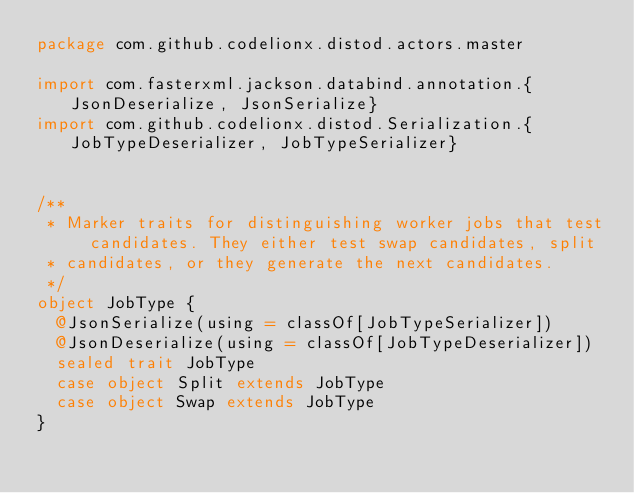<code> <loc_0><loc_0><loc_500><loc_500><_Scala_>package com.github.codelionx.distod.actors.master

import com.fasterxml.jackson.databind.annotation.{JsonDeserialize, JsonSerialize}
import com.github.codelionx.distod.Serialization.{JobTypeDeserializer, JobTypeSerializer}


/**
 * Marker traits for distinguishing worker jobs that test candidates. They either test swap candidates, split
 * candidates, or they generate the next candidates.
 */
object JobType {
  @JsonSerialize(using = classOf[JobTypeSerializer])
  @JsonDeserialize(using = classOf[JobTypeDeserializer])
  sealed trait JobType
  case object Split extends JobType
  case object Swap extends JobType
}
</code> 